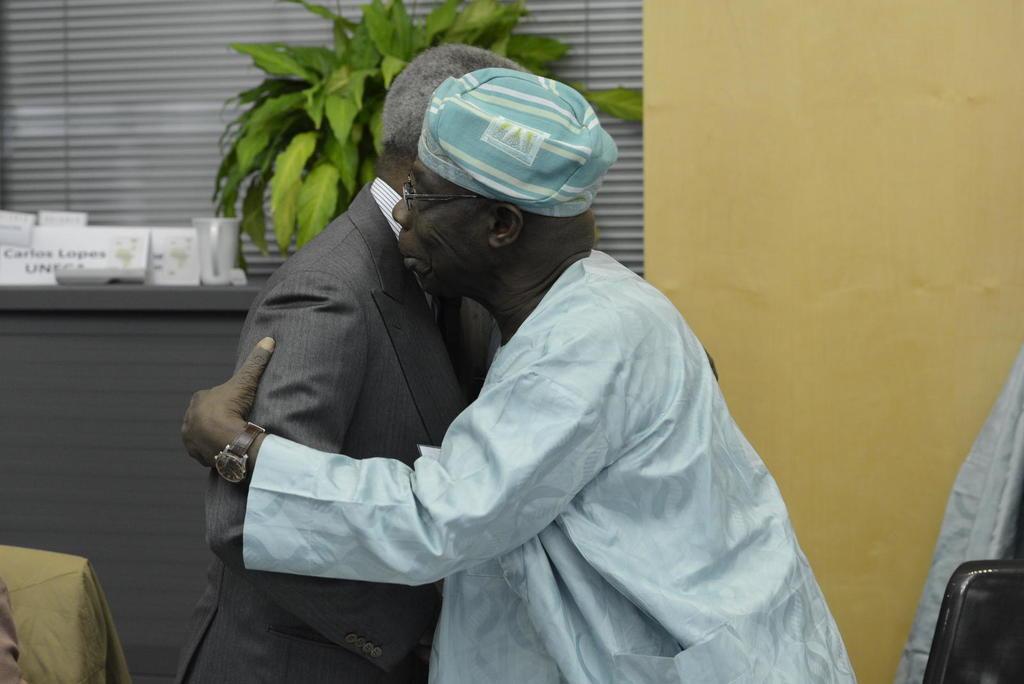Describe this image in one or two sentences. In this picture, we see two men are standing and they are hugging each other. The man on the right side is wearing the spectacles and a watch. In the right bottom, we see a chair and a sheet in blue color. In the left bottom, we see a chair. Behind that, we see a table in grey color on which the cups, name boards and flower pot are placed. In the background, we see a wall in yellow color and a window blind. 